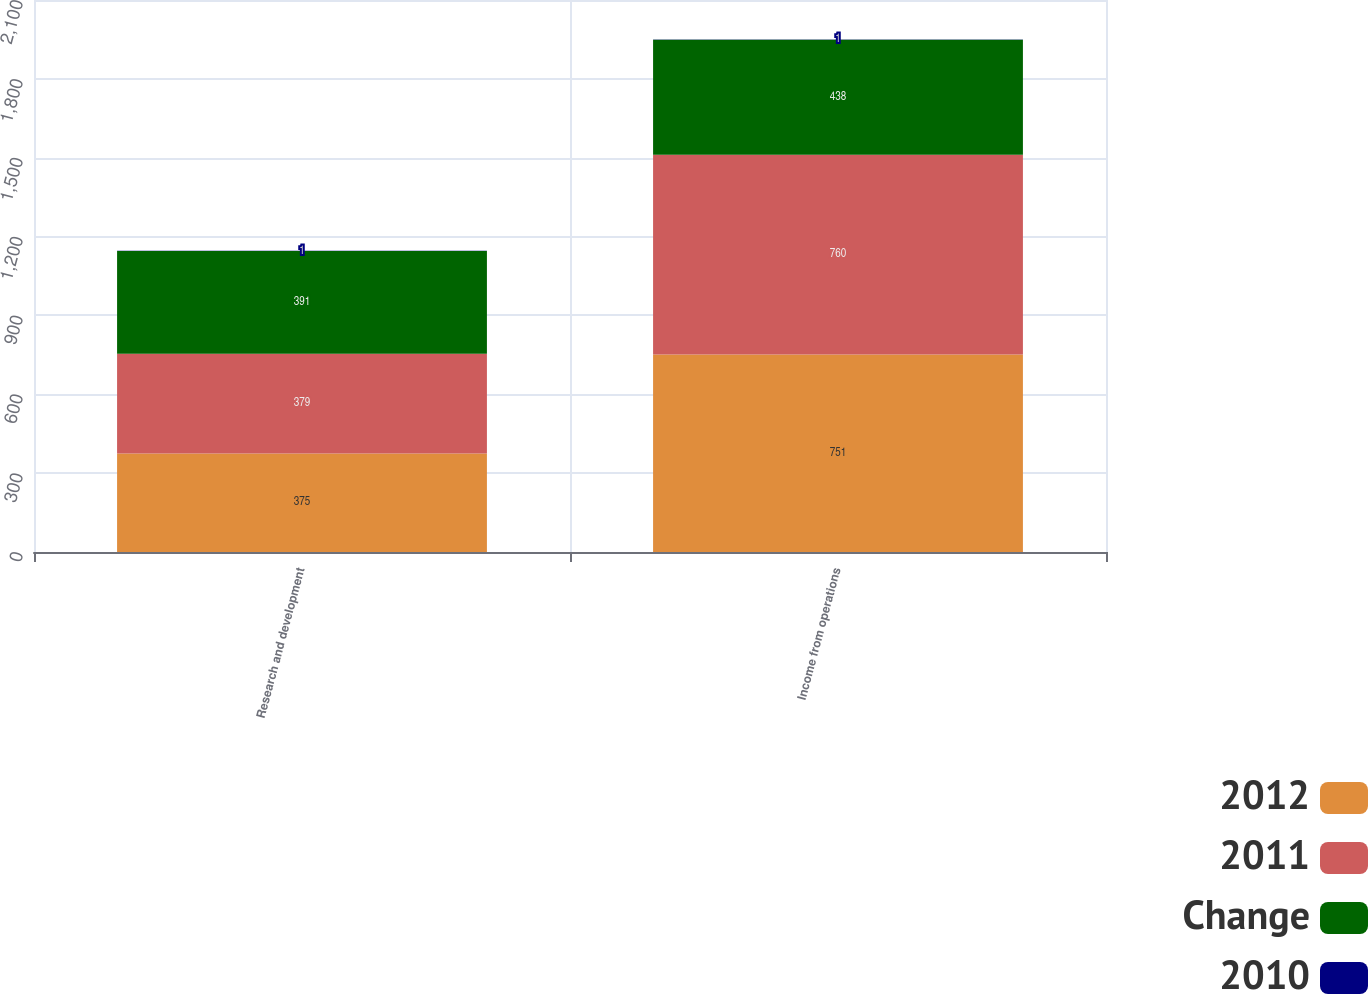<chart> <loc_0><loc_0><loc_500><loc_500><stacked_bar_chart><ecel><fcel>Research and development<fcel>Income from operations<nl><fcel>2012<fcel>375<fcel>751<nl><fcel>2011<fcel>379<fcel>760<nl><fcel>Change<fcel>391<fcel>438<nl><fcel>2010<fcel>1<fcel>1<nl></chart> 